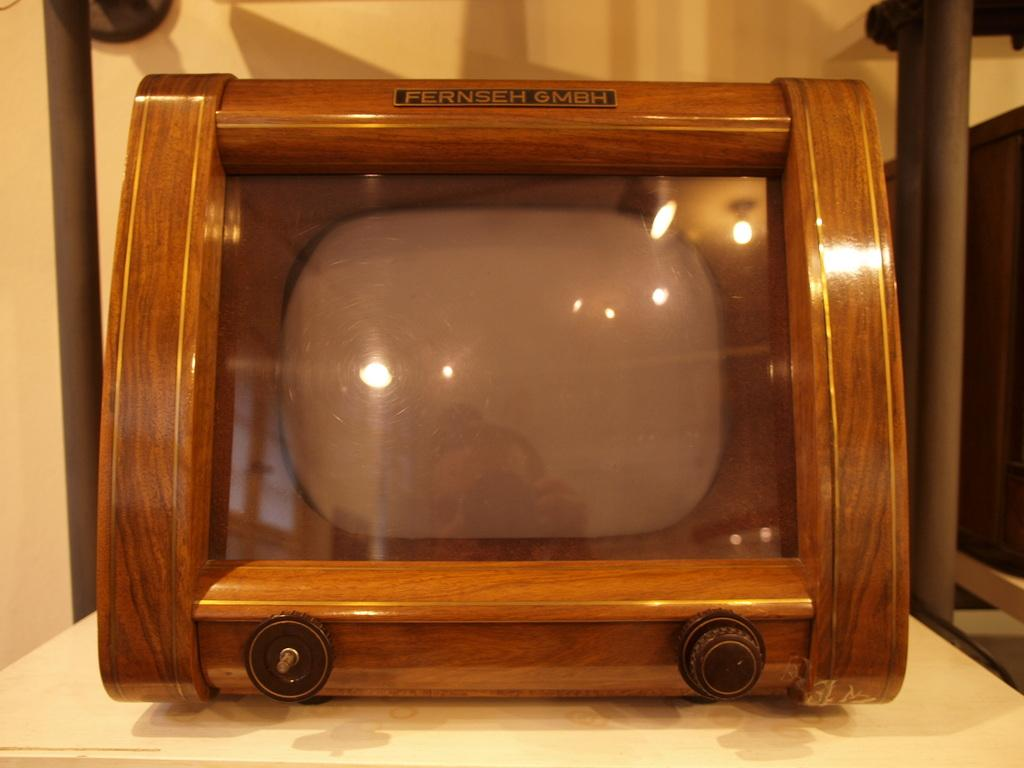<image>
Present a compact description of the photo's key features. An old television set by the Fernseh GMBH company. 